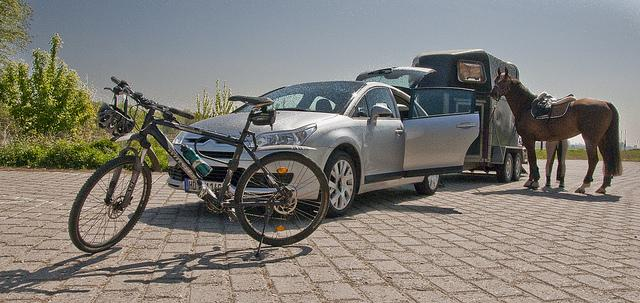What is being used to pull the black trailer? car 